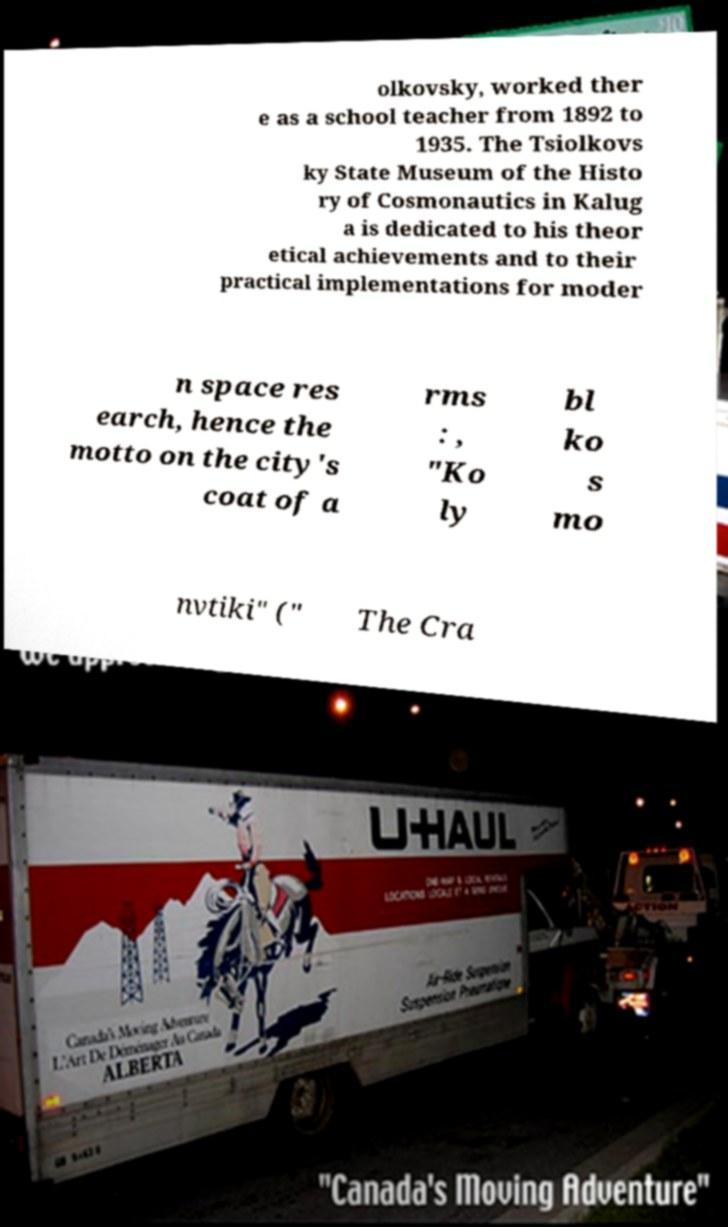I need the written content from this picture converted into text. Can you do that? olkovsky, worked ther e as a school teacher from 1892 to 1935. The Tsiolkovs ky State Museum of the Histo ry of Cosmonautics in Kalug a is dedicated to his theor etical achievements and to their practical implementations for moder n space res earch, hence the motto on the city's coat of a rms : , "Ko ly bl ko s mo nvtiki" (" The Cra 